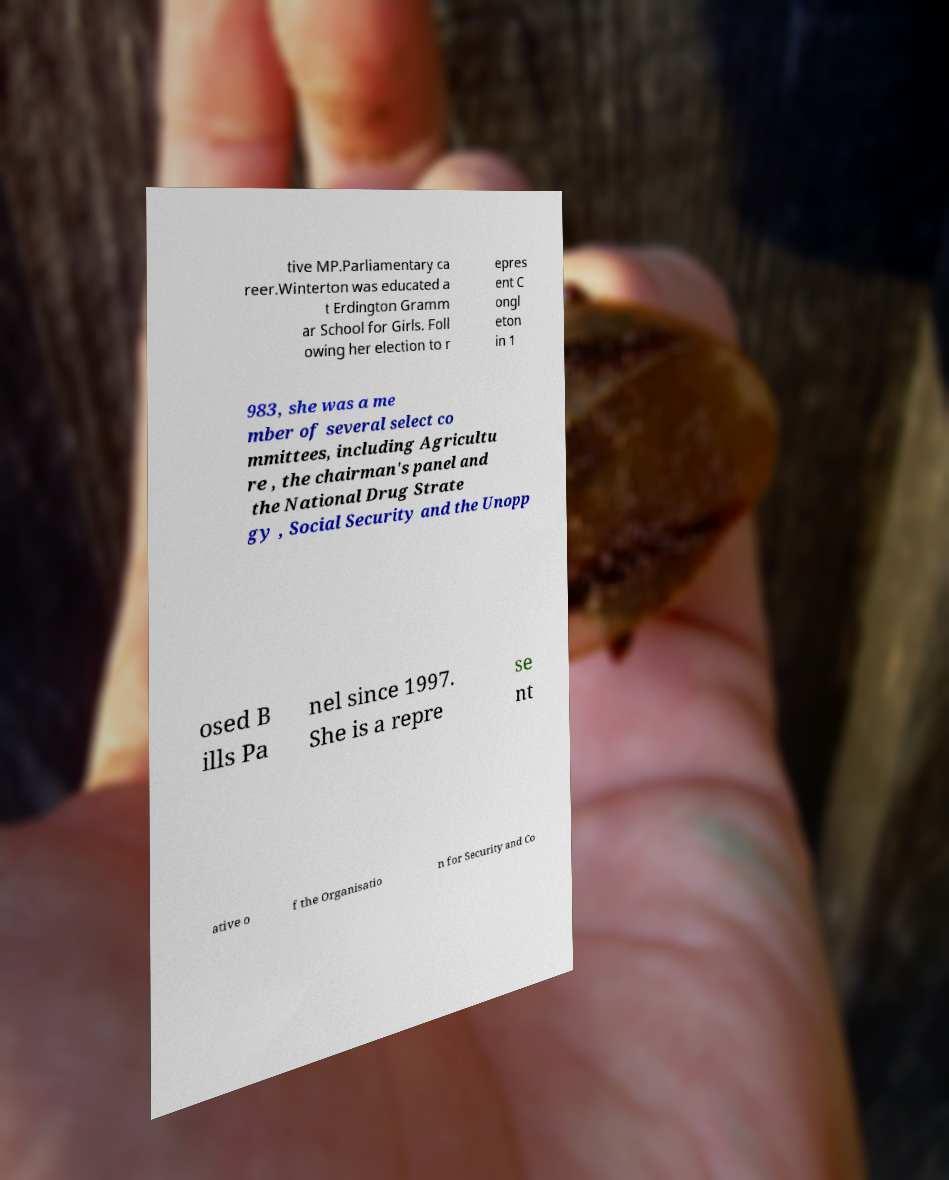There's text embedded in this image that I need extracted. Can you transcribe it verbatim? tive MP.Parliamentary ca reer.Winterton was educated a t Erdington Gramm ar School for Girls. Foll owing her election to r epres ent C ongl eton in 1 983, she was a me mber of several select co mmittees, including Agricultu re , the chairman's panel and the National Drug Strate gy , Social Security and the Unopp osed B ills Pa nel since 1997. She is a repre se nt ative o f the Organisatio n for Security and Co 